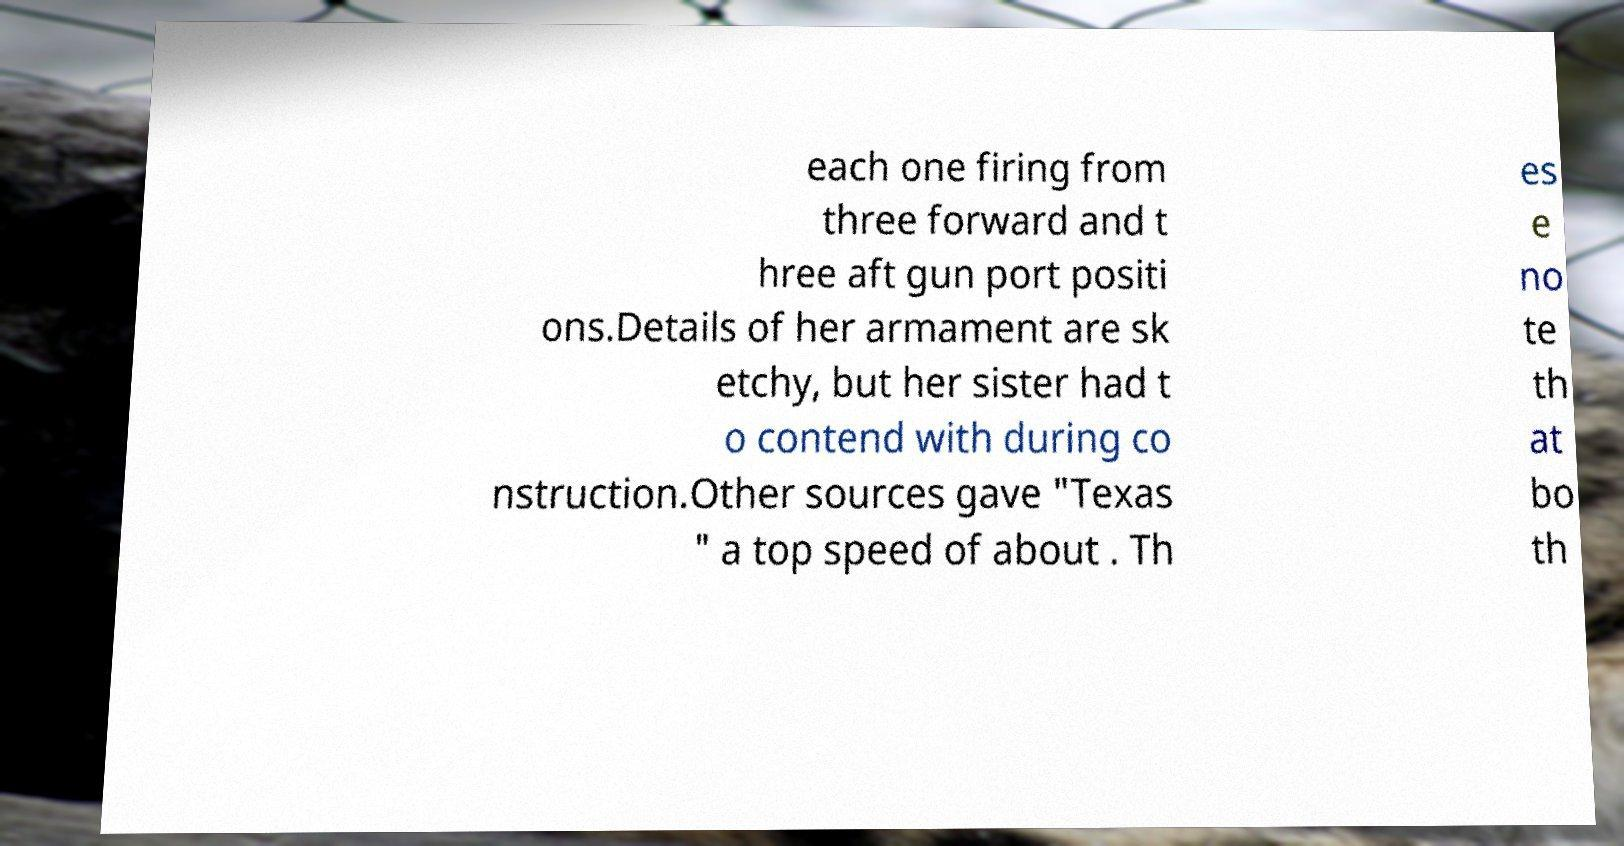Could you extract and type out the text from this image? each one firing from three forward and t hree aft gun port positi ons.Details of her armament are sk etchy, but her sister had t o contend with during co nstruction.Other sources gave "Texas " a top speed of about . Th es e no te th at bo th 